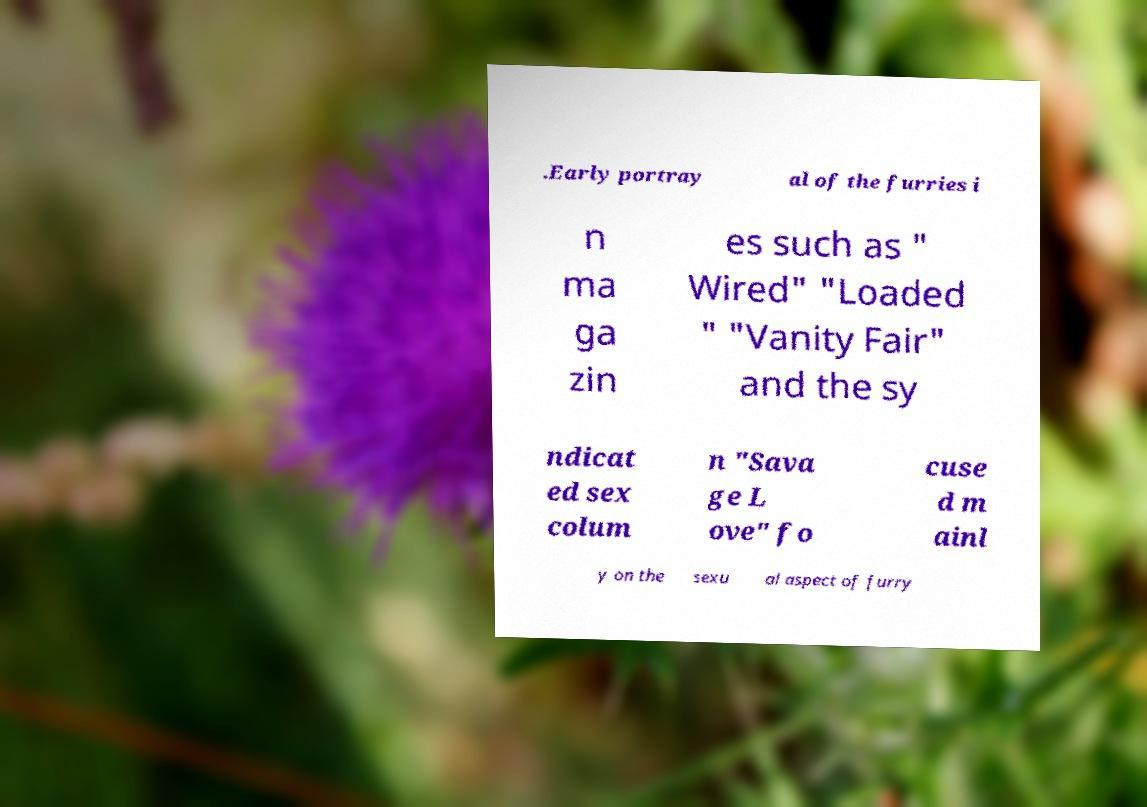I need the written content from this picture converted into text. Can you do that? .Early portray al of the furries i n ma ga zin es such as " Wired" "Loaded " "Vanity Fair" and the sy ndicat ed sex colum n "Sava ge L ove" fo cuse d m ainl y on the sexu al aspect of furry 